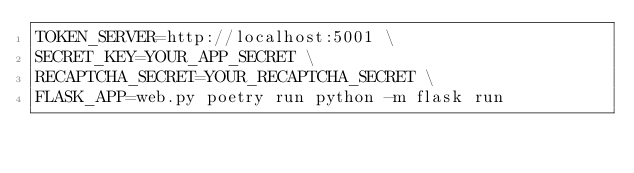Convert code to text. <code><loc_0><loc_0><loc_500><loc_500><_Bash_>TOKEN_SERVER=http://localhost:5001 \
SECRET_KEY=YOUR_APP_SECRET \
RECAPTCHA_SECRET=YOUR_RECAPTCHA_SECRET \
FLASK_APP=web.py poetry run python -m flask run</code> 